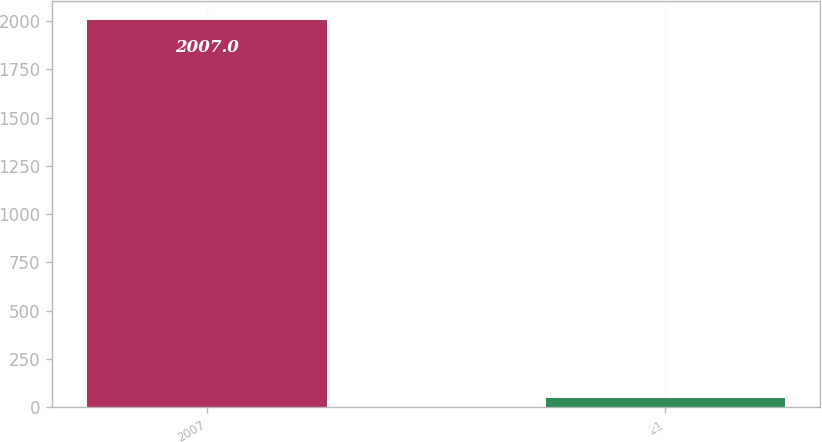<chart> <loc_0><loc_0><loc_500><loc_500><bar_chart><fcel>2007<fcel>21<nl><fcel>2007<fcel>47<nl></chart> 